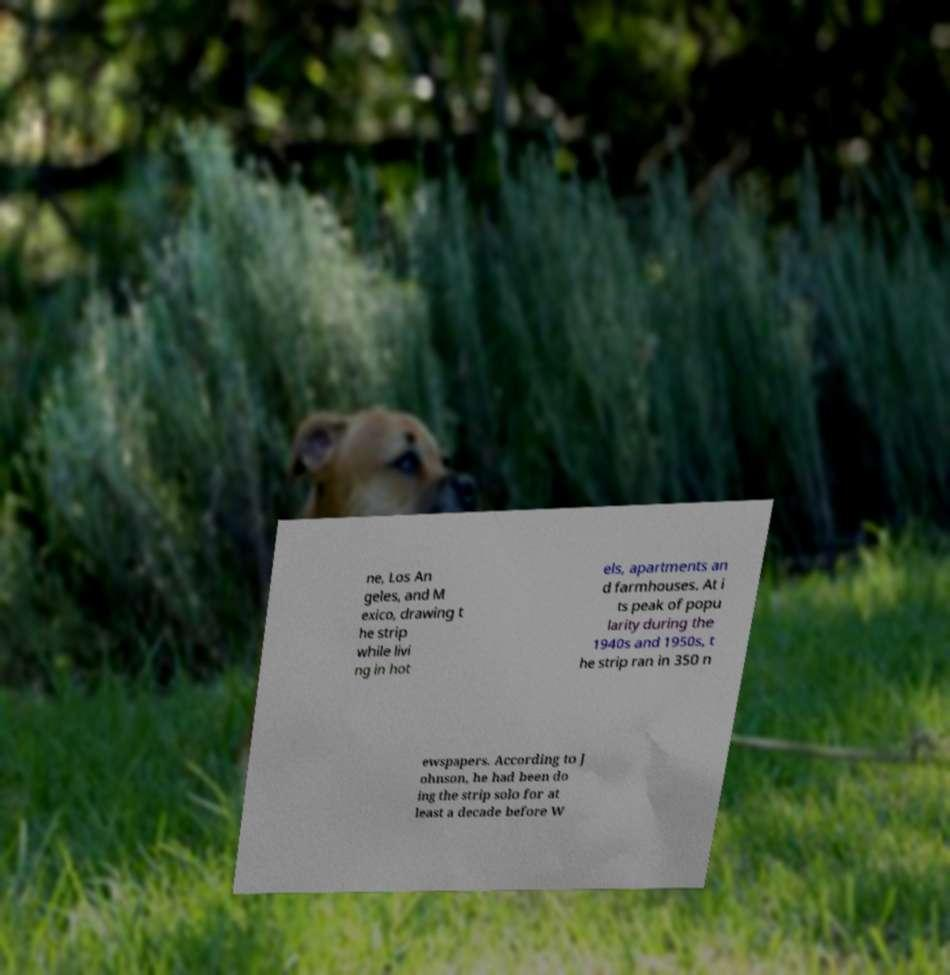What messages or text are displayed in this image? I need them in a readable, typed format. ne, Los An geles, and M exico, drawing t he strip while livi ng in hot els, apartments an d farmhouses. At i ts peak of popu larity during the 1940s and 1950s, t he strip ran in 350 n ewspapers. According to J ohnson, he had been do ing the strip solo for at least a decade before W 